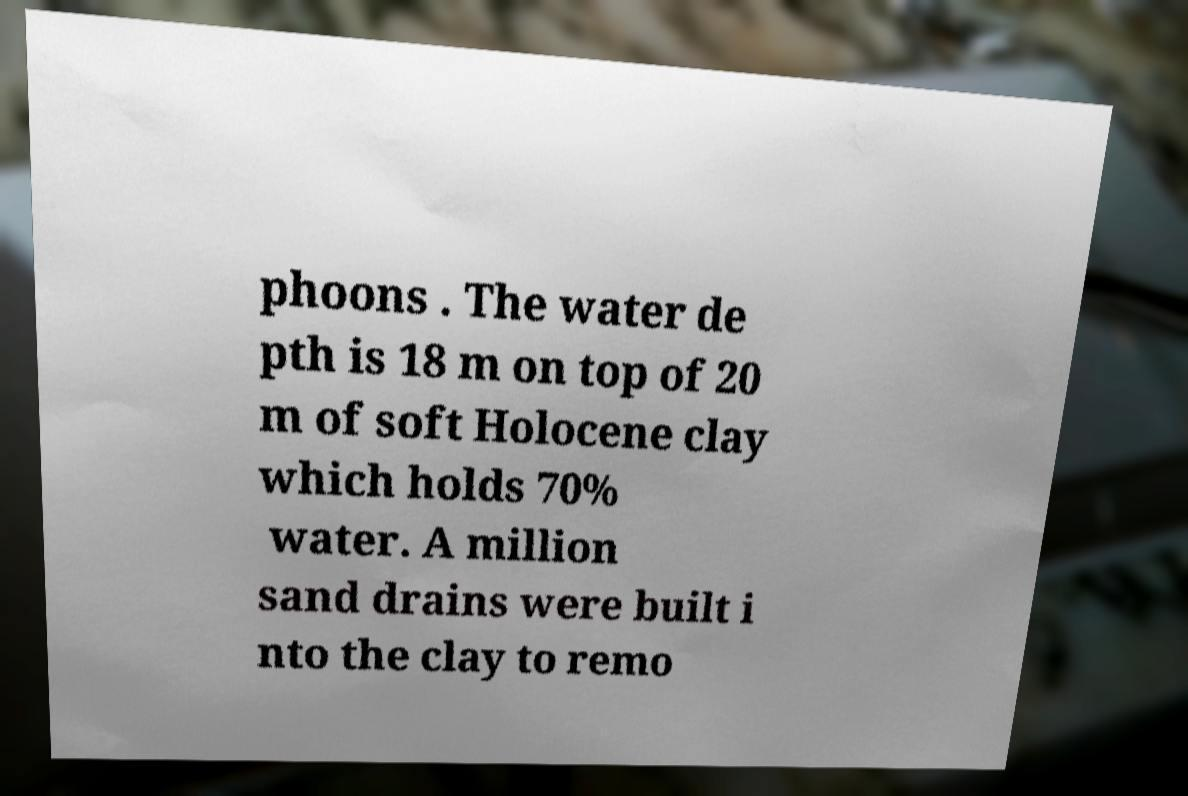I need the written content from this picture converted into text. Can you do that? phoons . The water de pth is 18 m on top of 20 m of soft Holocene clay which holds 70% water. A million sand drains were built i nto the clay to remo 